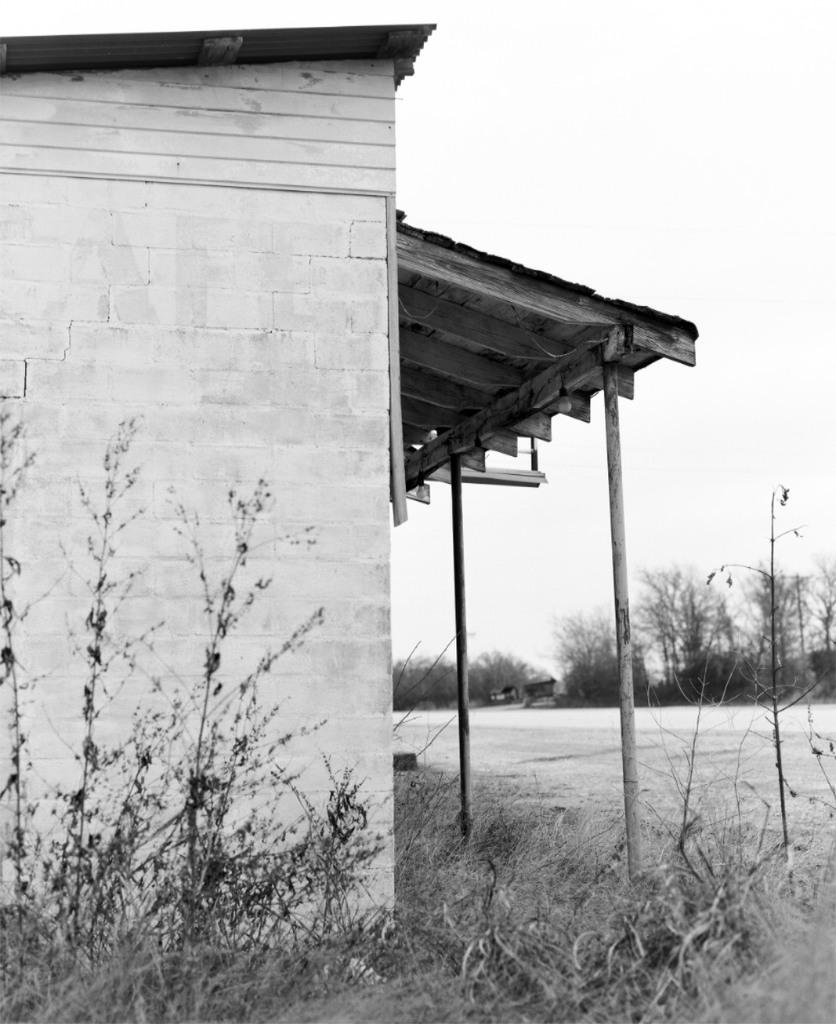What type of house is shown in the picture? There is a roofing sheet house in the picture. Are there any plants near the house? Yes, there are plants beside the house. Can you describe the background of the picture? There are other plants visible in the background of the picture. What type of brass material is used for the lace in the picture? There is no brass or lace present in the picture; it features a roofing sheet house and plants. 